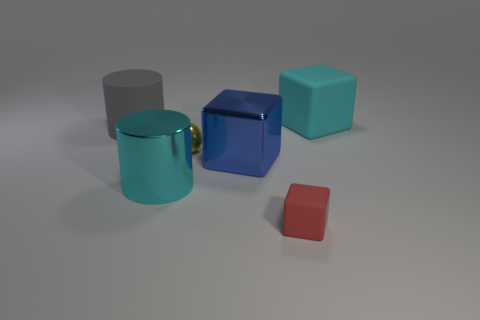Subtract all red blocks. How many blocks are left? 2 Subtract 2 blocks. How many blocks are left? 1 Subtract all balls. How many objects are left? 5 Subtract all blue blocks. How many blocks are left? 2 Add 1 big cyan metallic cylinders. How many objects exist? 7 Subtract 0 purple cylinders. How many objects are left? 6 Subtract all red balls. Subtract all brown cubes. How many balls are left? 1 Subtract all gray cylinders. How many gray blocks are left? 0 Subtract all large blue things. Subtract all small red cubes. How many objects are left? 4 Add 2 cyan cylinders. How many cyan cylinders are left? 3 